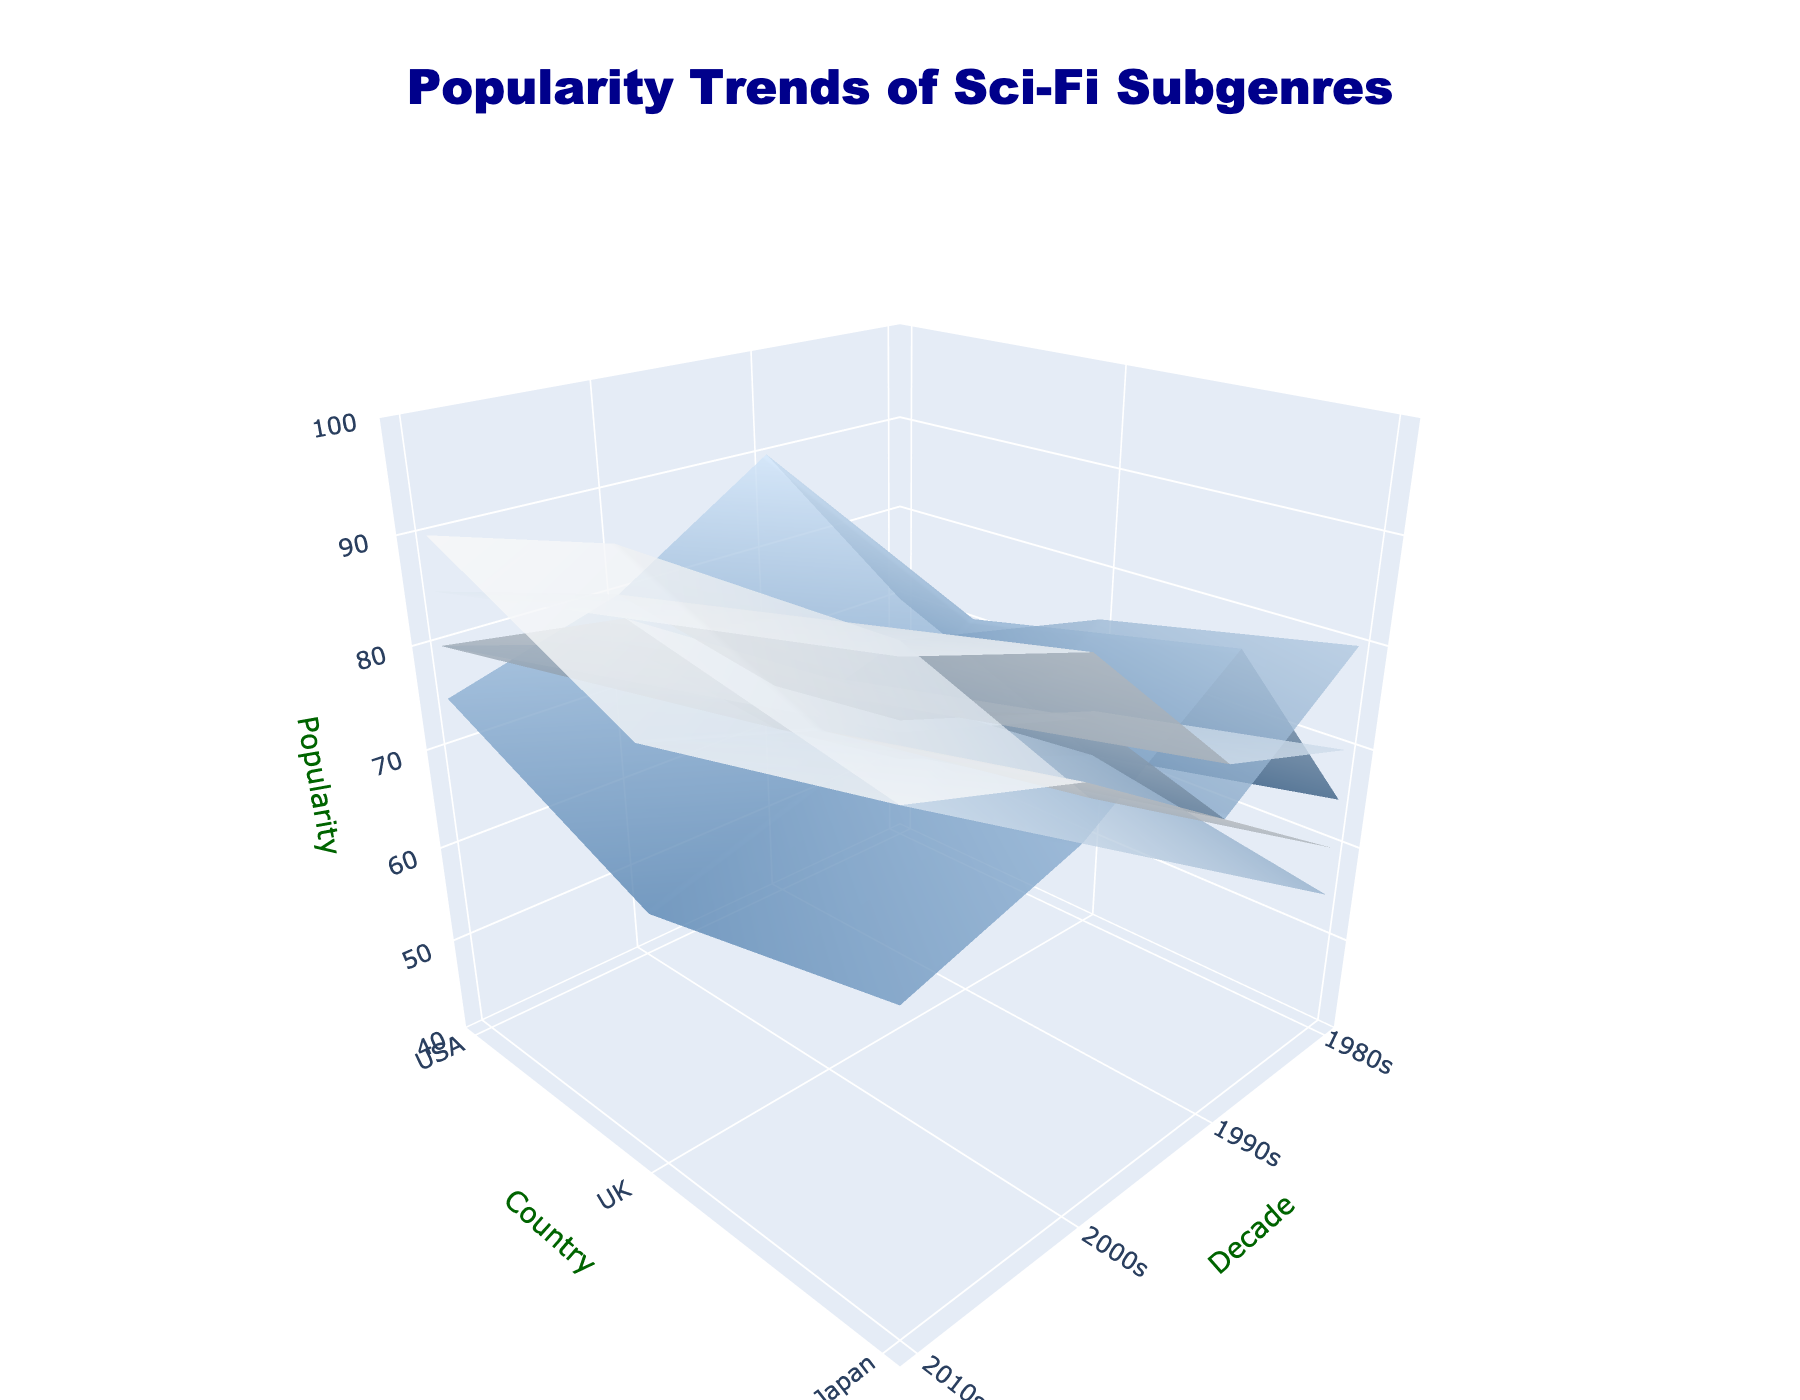What is the title of the plot? The title of the plot is usually found at the top of the figure. In this case, it is "Popularity Trends of Sci-Fi Subgenres".
Answer: Popularity Trends of Sci-Fi Subgenres What does the z-axis represent in the plot? The z-axis title indicates what the z-axis represents. Here, it is labeled "Popularity", so the z-axis represents the popularity of the sci-fi subgenres.
Answer: Popularity Which subgenre has the highest popularity in the USA in the 2010s? Inspect each surface for the USA in the 2010s. The Dystopian subgenre reaches the highest z-value on the plot.
Answer: Dystopian Between the 1990s and 2000s, how did the popularity of the Cyberpunk subgenre change in the UK? Look at the respective surfaces for Cyberpunk in the UK across the 1990s and 2000s. The popularity dropped from 80 in the 1990s to 70 in the 2000s, showing a decrease.
Answer: Decreased Which country experienced the highest popularity for the First Contact subgenre in the 2000s? Check the First Contact surface for the 2000s. Japan has the highest z-value (85) compared to the USA (80) and the UK (75).
Answer: Japan In the 1980s, which subgenre was more popular in Japan compared to the UK? Compare the z-values for Japan and the UK in the 1980s for each subgenre. Cyberpunk (70 > 60) and First Contact (65 > 55) were more popular in Japan.
Answer: Cyberpunk and First Contact How did the Space Opera subgenre's popularity trend in the USA from the 1980s to the 2010s? Look at the z-values for Space Opera in the USA from each decade: 1980s (80), 1990s (70), 2000s (85), 2010s (90). There was a dip in the 1990s but an overall increasing trend.
Answer: Increasing trend overall Which country's popularity for Time Travel peaked in the 2010s? Examine the Time Travel surface for the 2010s across all countries. The UK reaches a z-value of 90, which is the highest compared to the USA (85) and Japan (80).
Answer: UK What is the general trend of the Dystopian subgenre in the UK from the 1980s to the 2010s? Review the Dystopian values for the UK across the decades: 1980s (65), 1990s (70), 2000s (85), 2010s (90). There is a consistent upward trend.
Answer: Increasing What's the average popularity of the Space Opera subgenre across all countries in the 2010s? Sum the z-values for Space Opera in the 2010s (USA 90, UK 85, Japan 80), and divide by the number of countries (3). (90 + 85 + 80) / 3 = 85
Answer: 85 